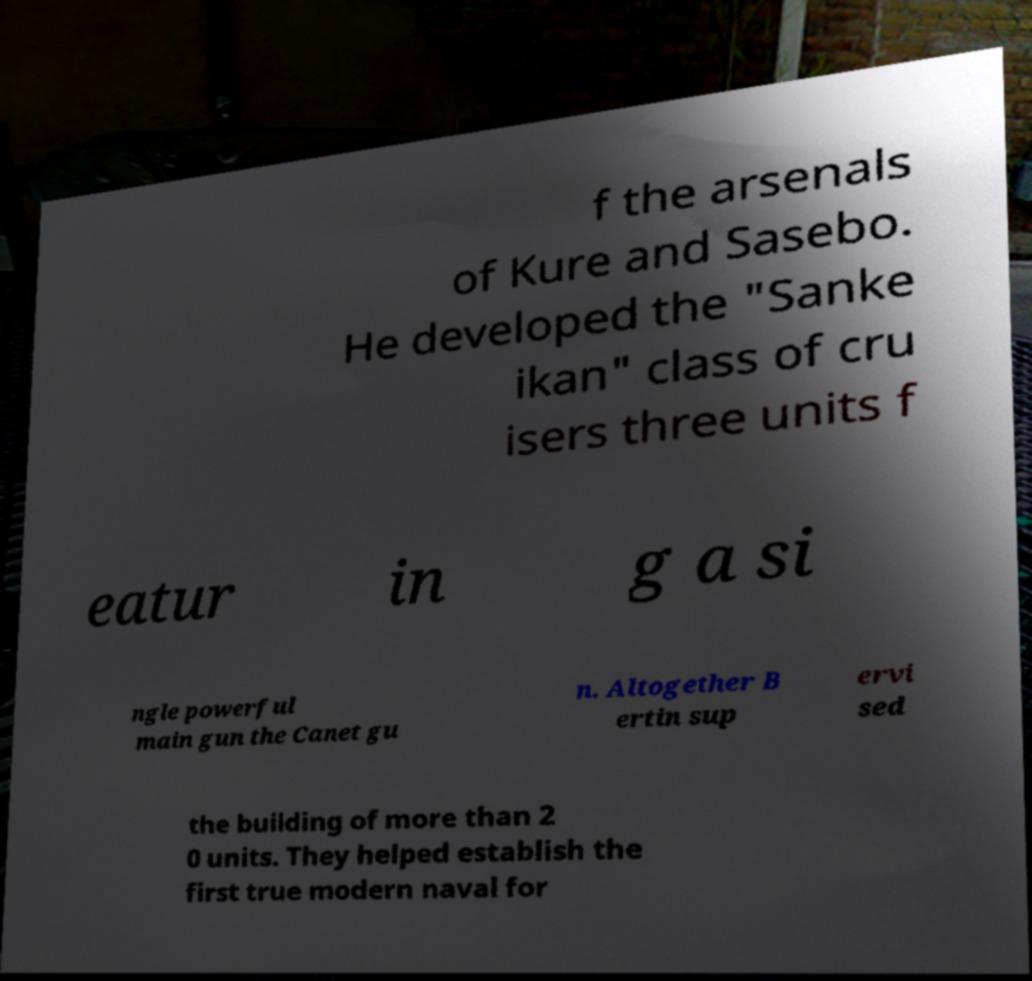I need the written content from this picture converted into text. Can you do that? f the arsenals of Kure and Sasebo. He developed the "Sanke ikan" class of cru isers three units f eatur in g a si ngle powerful main gun the Canet gu n. Altogether B ertin sup ervi sed the building of more than 2 0 units. They helped establish the first true modern naval for 